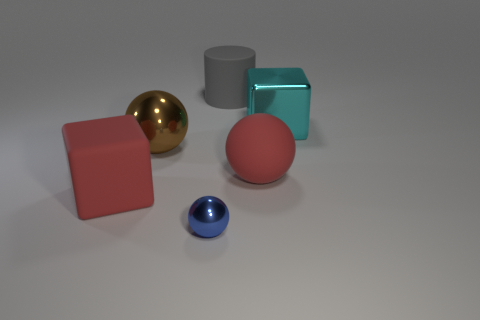Add 2 gray cylinders. How many objects exist? 8 Subtract all blocks. How many objects are left? 4 Subtract 0 purple blocks. How many objects are left? 6 Subtract all large gray things. Subtract all cyan cubes. How many objects are left? 4 Add 4 large objects. How many large objects are left? 9 Add 3 brown metallic spheres. How many brown metallic spheres exist? 4 